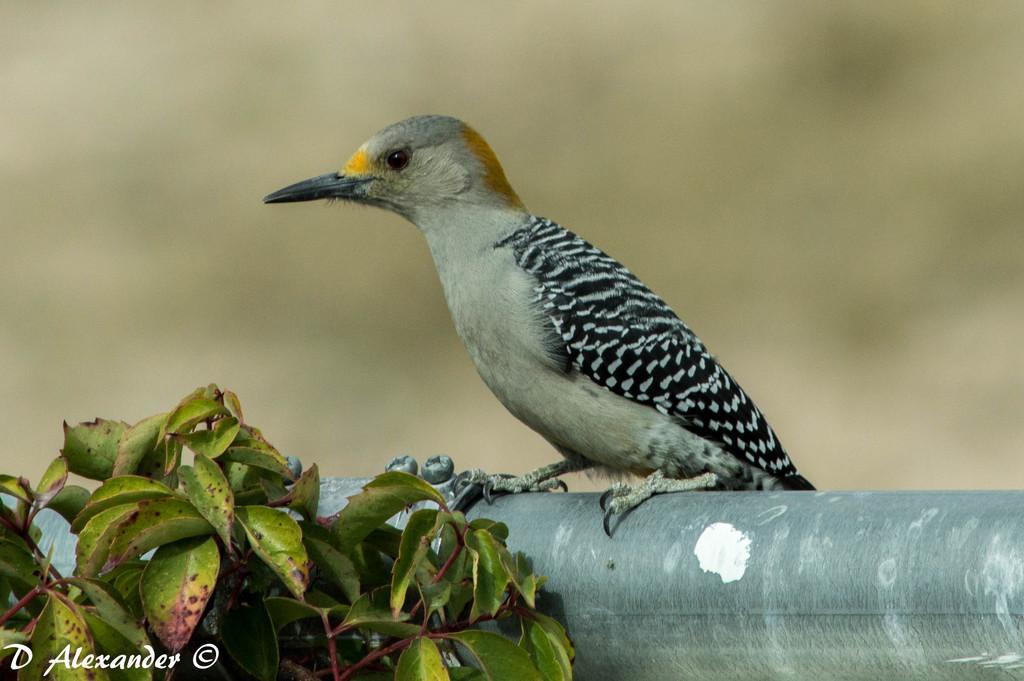How would you summarize this image in a sentence or two? This picture contains a bird which is in black color and it has a long beak. Beside that, we see a tree. In the background, it is blurred. 